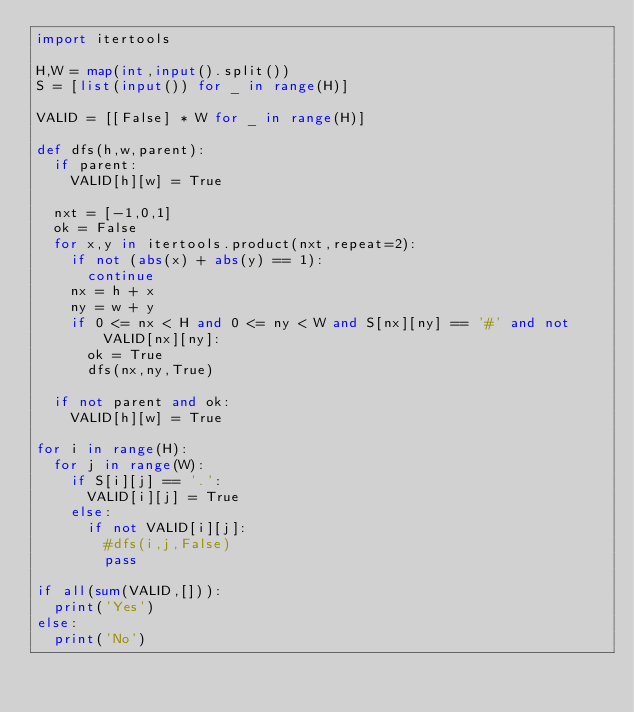<code> <loc_0><loc_0><loc_500><loc_500><_Python_>import itertools

H,W = map(int,input().split())
S = [list(input()) for _ in range(H)]

VALID = [[False] * W for _ in range(H)]

def dfs(h,w,parent):
  if parent:
    VALID[h][w] = True

  nxt = [-1,0,1]
  ok = False
  for x,y in itertools.product(nxt,repeat=2):
    if not (abs(x) + abs(y) == 1):
      continue
    nx = h + x
    ny = w + y
    if 0 <= nx < H and 0 <= ny < W and S[nx][ny] == '#' and not VALID[nx][ny]:
      ok = True
      dfs(nx,ny,True)
  
  if not parent and ok:
    VALID[h][w] = True
      
for i in range(H):
  for j in range(W):
    if S[i][j] == '.':
      VALID[i][j] = True
    else:
      if not VALID[i][j]:
        #dfs(i,j,False)
        pass
        
if all(sum(VALID,[])):
  print('Yes')
else:
  print('No')
</code> 